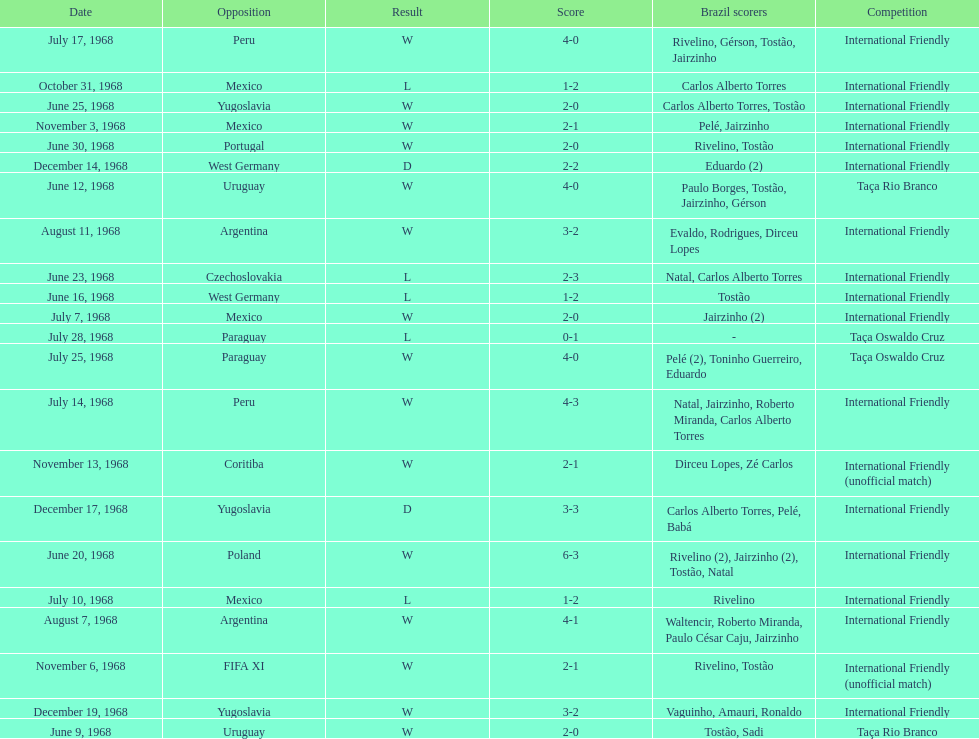What year has the highest scoring game? 1968. 